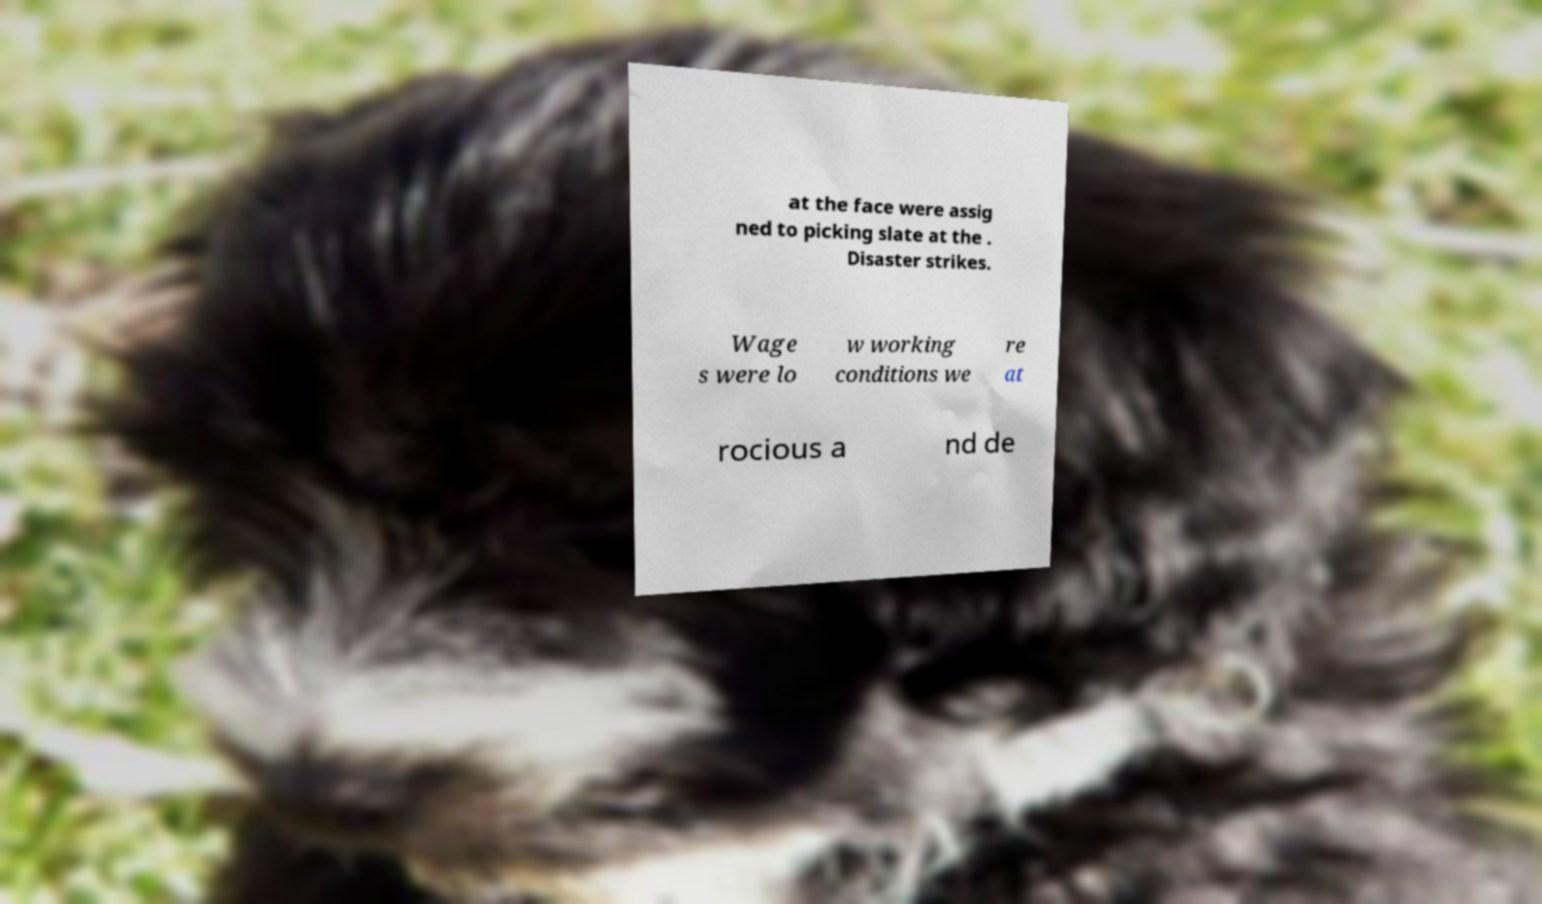Could you extract and type out the text from this image? at the face were assig ned to picking slate at the . Disaster strikes. Wage s were lo w working conditions we re at rocious a nd de 